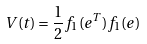<formula> <loc_0><loc_0><loc_500><loc_500>V ( t ) = \frac { 1 } { 2 } { f } _ { 1 } ( { e } ^ { T } ) { f } _ { 1 } ( { e } )</formula> 